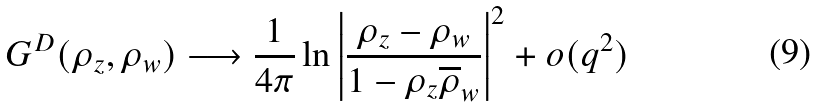<formula> <loc_0><loc_0><loc_500><loc_500>G ^ { D } ( \rho _ { z } , \rho _ { w } ) \longrightarrow \frac { 1 } { 4 \pi } \ln \left | \frac { \rho _ { z } - \rho _ { w } } { 1 - \rho _ { z } \overline { \rho } _ { w } } \right | ^ { 2 } + o ( q ^ { 2 } )</formula> 